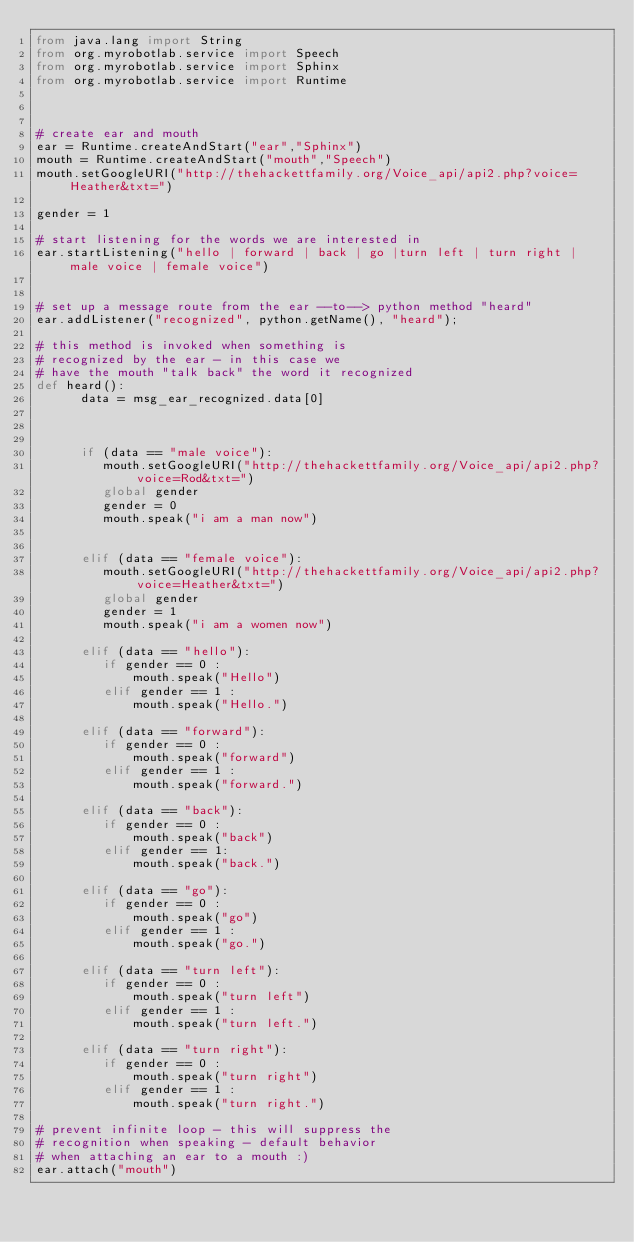<code> <loc_0><loc_0><loc_500><loc_500><_Python_>from java.lang import String
from org.myrobotlab.service import Speech
from org.myrobotlab.service import Sphinx
from org.myrobotlab.service import Runtime



# create ear and mouth
ear = Runtime.createAndStart("ear","Sphinx")
mouth = Runtime.createAndStart("mouth","Speech")
mouth.setGoogleURI("http://thehackettfamily.org/Voice_api/api2.php?voice=Heather&txt=")

gender = 1

# start listening for the words we are interested in
ear.startListening("hello | forward | back | go |turn left | turn right | male voice | female voice")


# set up a message route from the ear --to--> python method "heard"
ear.addListener("recognized", python.getName(), "heard"); 

# this method is invoked when something is 
# recognized by the ear - in this case we
# have the mouth "talk back" the word it recognized
def heard():
      data = msg_ear_recognized.data[0]

    
      
      if (data == "male voice"):
         mouth.setGoogleURI("http://thehackettfamily.org/Voice_api/api2.php?voice=Rod&txt=")
         global gender
         gender = 0
         mouth.speak("i am a man now")
         
         
      elif (data == "female voice"):
         mouth.setGoogleURI("http://thehackettfamily.org/Voice_api/api2.php?voice=Heather&txt=")
         global gender
         gender = 1
         mouth.speak("i am a women now")

      elif (data == "hello"):
         if gender == 0 :
             mouth.speak("Hello")
         elif gender == 1 :
             mouth.speak("Hello.")

      elif (data == "forward"):
         if gender == 0 :
             mouth.speak("forward")
         elif gender == 1 :
             mouth.speak("forward.")

      elif (data == "back"):
         if gender == 0 :
             mouth.speak("back")
         elif gender == 1:
             mouth.speak("back.")

      elif (data == "go"):
         if gender == 0 :
             mouth.speak("go")
         elif gender == 1 :
             mouth.speak("go.")

      elif (data == "turn left"):
         if gender == 0 :
             mouth.speak("turn left")
         elif gender == 1 :
             mouth.speak("turn left.")
             
      elif (data == "turn right"):
         if gender == 0 :
             mouth.speak("turn right")
         elif gender == 1 :
             mouth.speak("turn right.")
    
# prevent infinite loop - this will suppress the
# recognition when speaking - default behavior
# when attaching an ear to a mouth :)
ear.attach("mouth")





</code> 